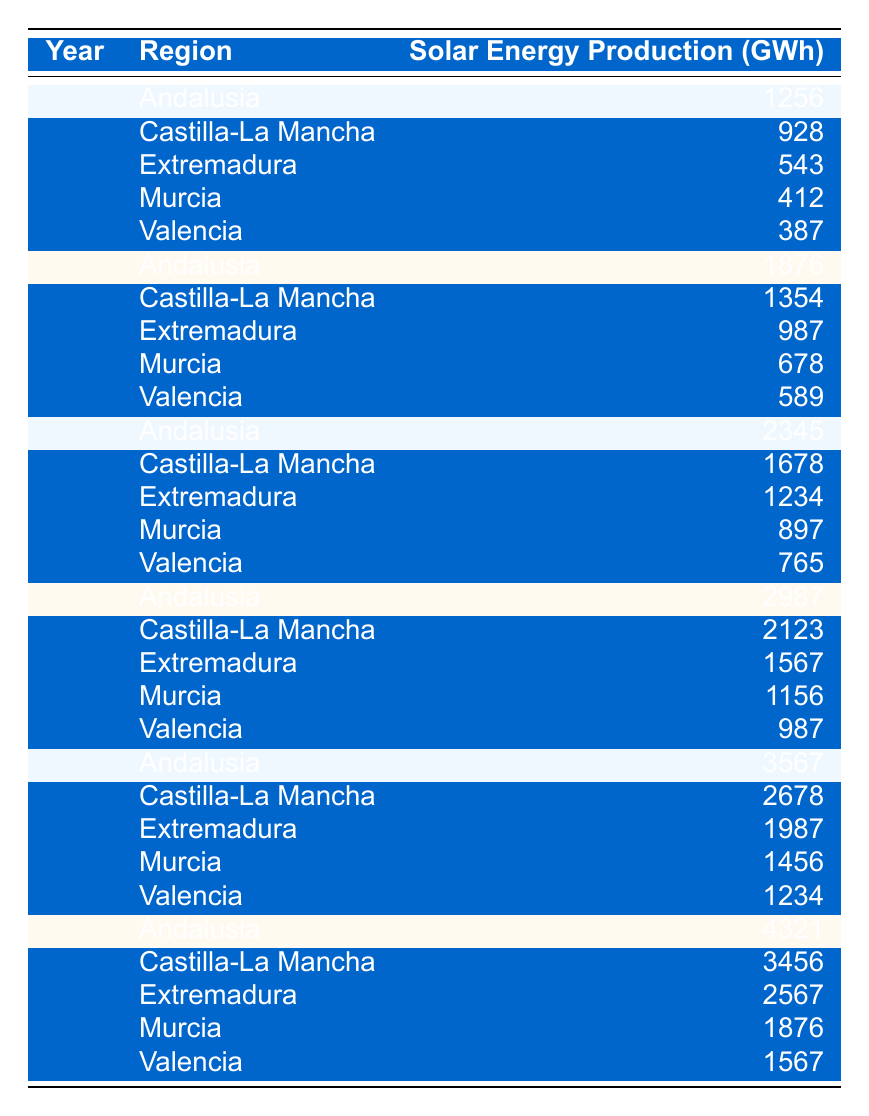What was the solar energy production in Andalusia in 2014? Referring to the table, in 2014, the solar energy production for Andalusia is listed as 2345 GWh.
Answer: 2345 GWh Which region had the highest solar energy production in 2020? According to the table, in 2020, Andalusia had the highest solar energy production at 4321 GWh.
Answer: Andalusia What was the solar energy production in Castilla-La Mancha in 2012? The table shows that in 2012, the solar energy production in Castilla-La Mancha was 1354 GWh.
Answer: 1354 GWh What is the difference in solar energy production between Extremadura in 2010 and 2020? In 2010, the solar energy production in Extremadura was 543 GWh, and in 2020 it was 2567 GWh. The difference is calculated as 2567 GWh - 543 GWh = 2024 GWh.
Answer: 2024 GWh What was the average solar energy production in Murcia from 2010 to 2020? The values for Murcia are 412 GWh (2010), 678 GWh (2012), 897 GWh (2014), 1156 GWh (2016), 1456 GWh (2018), and 1876 GWh (2020). Summing these values gives 412 + 678 + 897 + 1156 + 1456 + 1876 = 5575 GWh. There are 6 years, so the average is 5575 GWh / 6 = 929.17 GWh.
Answer: Approximately 929.17 GWh Was the solar energy production in Valencia increasing every year from 2010 to 2020? According to the table, the values for Valencia are 387 GWh (2010), 589 GWh (2012), 765 GWh (2014), 987 GWh (2016), 1234 GWh (2018), and 1567 GWh (2020). Each year shows an increase, verifying a steady growth in production.
Answer: Yes Which region had the least solar energy production in 2016? The table lists the solar energy production in 2016: Andalusia (2987 GWh), Castilla-La Mancha (2123 GWh), Extremadura (1567 GWh), Murcia (1156 GWh), and Valencia (987 GWh). Hence, Valencia had the least production at 987 GWh.
Answer: Valencia How much total solar energy was produced in Extremadura from 2010 to 2020? The table shows the following values for Extremadura: 543 GWh (2010), 987 GWh (2012), 1234 GWh (2014), 1567 GWh (2016), 1987 GWh (2018), and 2567 GWh (2020). Adding these gives 543 + 987 + 1234 + 1567 + 1987 + 2567 = 10655 GWh.
Answer: 10655 GWh What was the rate of increase in solar energy production in Andalusia from 2010 to 2020? In 2010, production was 1256 GWh, and in 2020, it increased to 4321 GWh. The increase can be calculated as 4321 GWh - 1256 GWh = 3065 GWh. The rate of increase over 10 years is (3065 GWh / 10 years) = 306.5 GWh per year.
Answer: 306.5 GWh per year 